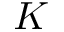Convert formula to latex. <formula><loc_0><loc_0><loc_500><loc_500>K</formula> 